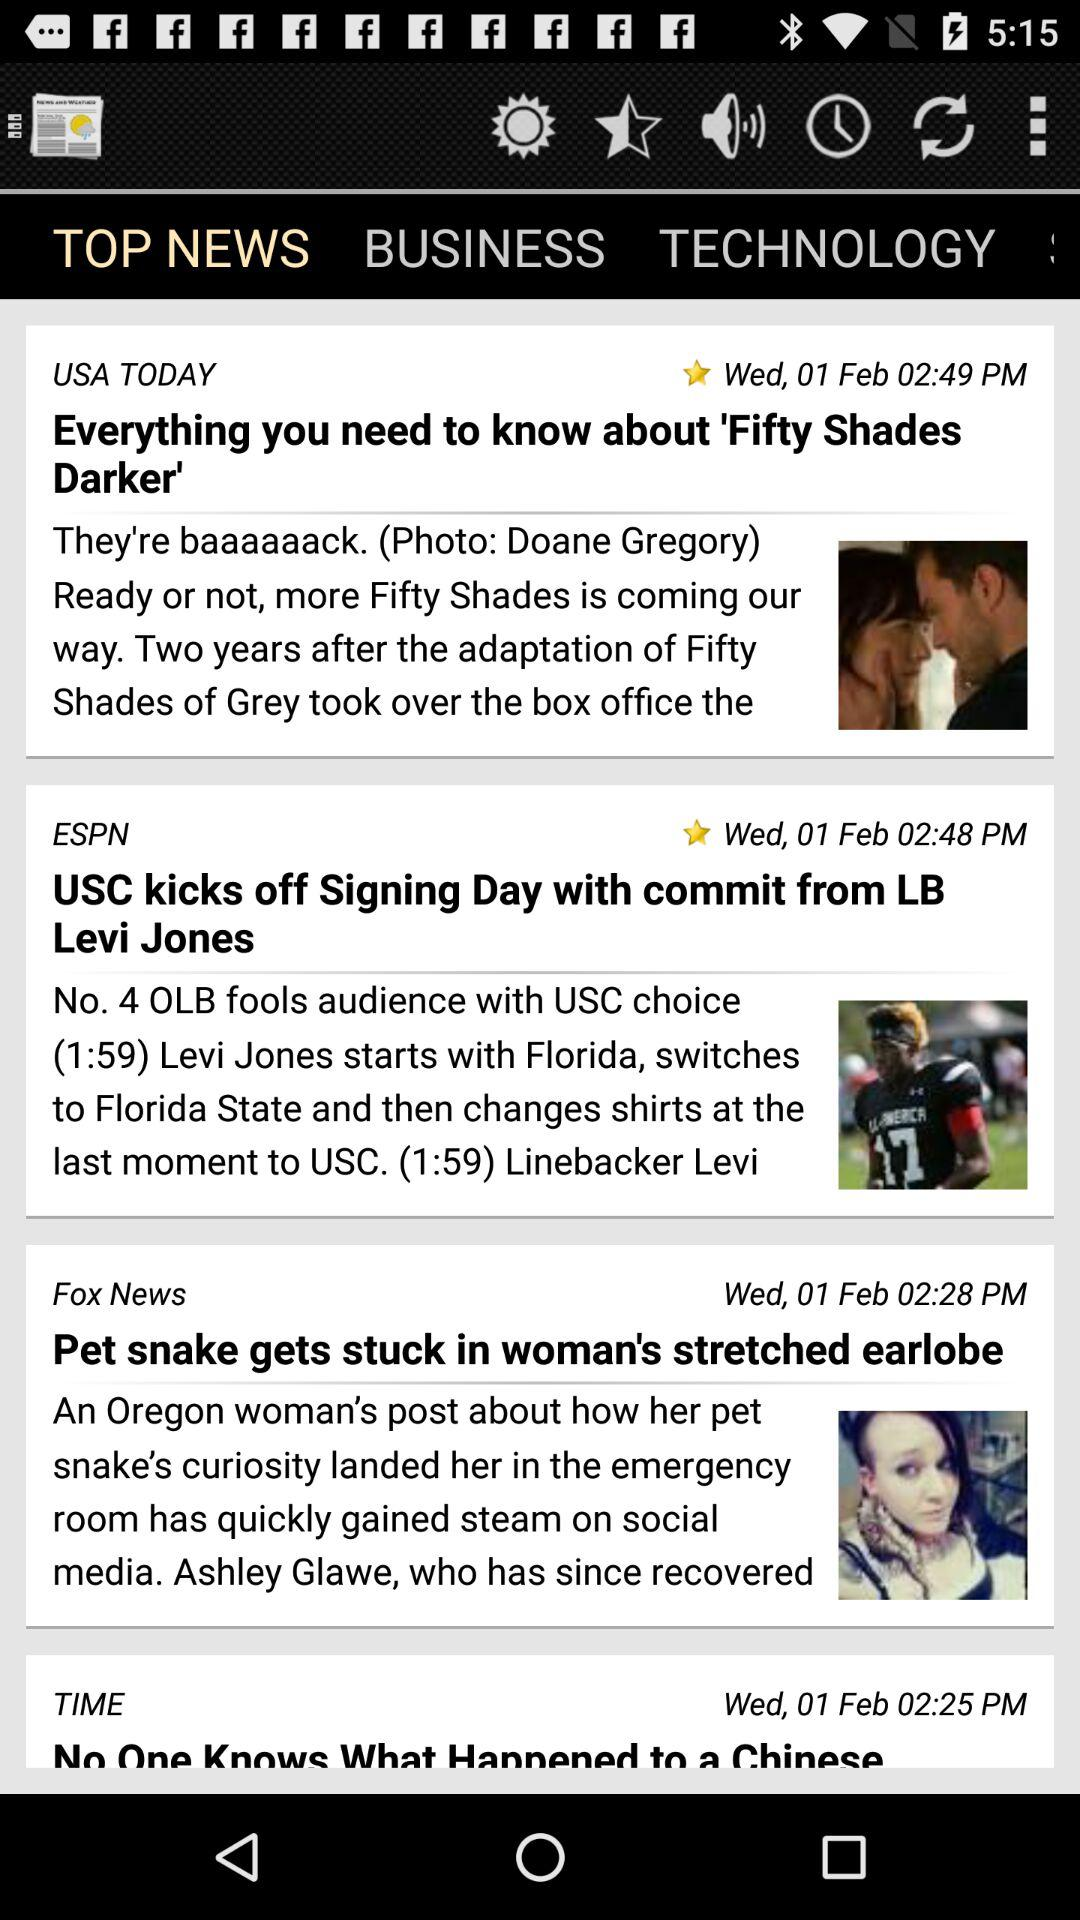On what date was the news "Everything you need to know about 'Fifty Shades Darker'" posted? The news was posted on Wednesday, February 1. 